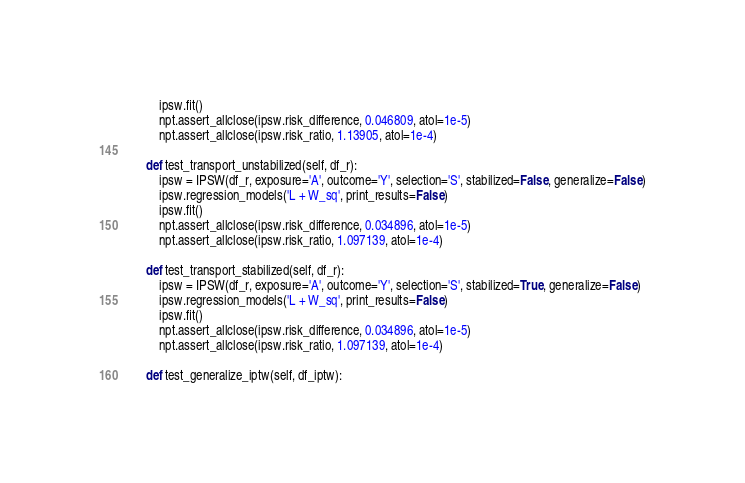Convert code to text. <code><loc_0><loc_0><loc_500><loc_500><_Python_>        ipsw.fit()
        npt.assert_allclose(ipsw.risk_difference, 0.046809, atol=1e-5)
        npt.assert_allclose(ipsw.risk_ratio, 1.13905, atol=1e-4)

    def test_transport_unstabilized(self, df_r):
        ipsw = IPSW(df_r, exposure='A', outcome='Y', selection='S', stabilized=False, generalize=False)
        ipsw.regression_models('L + W_sq', print_results=False)
        ipsw.fit()
        npt.assert_allclose(ipsw.risk_difference, 0.034896, atol=1e-5)
        npt.assert_allclose(ipsw.risk_ratio, 1.097139, atol=1e-4)

    def test_transport_stabilized(self, df_r):
        ipsw = IPSW(df_r, exposure='A', outcome='Y', selection='S', stabilized=True, generalize=False)
        ipsw.regression_models('L + W_sq', print_results=False)
        ipsw.fit()
        npt.assert_allclose(ipsw.risk_difference, 0.034896, atol=1e-5)
        npt.assert_allclose(ipsw.risk_ratio, 1.097139, atol=1e-4)

    def test_generalize_iptw(self, df_iptw):</code> 